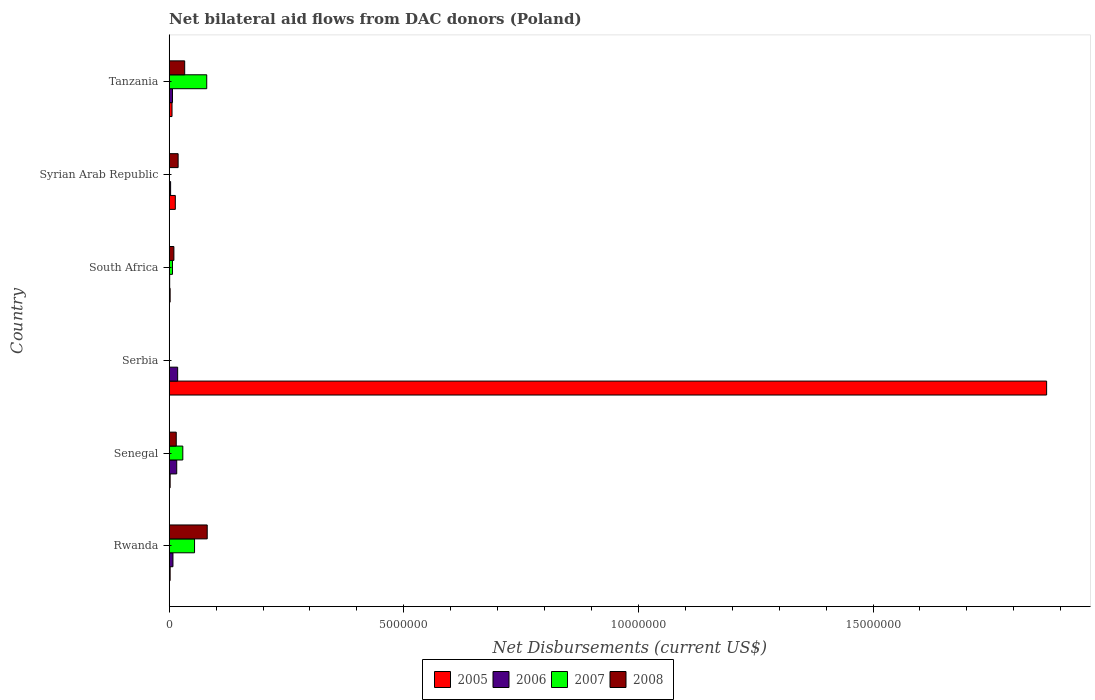How many groups of bars are there?
Provide a succinct answer. 6. Are the number of bars per tick equal to the number of legend labels?
Offer a very short reply. No. Are the number of bars on each tick of the Y-axis equal?
Keep it short and to the point. No. How many bars are there on the 2nd tick from the bottom?
Make the answer very short. 4. What is the label of the 6th group of bars from the top?
Your answer should be very brief. Rwanda. In how many cases, is the number of bars for a given country not equal to the number of legend labels?
Provide a succinct answer. 2. Across all countries, what is the maximum net bilateral aid flows in 2005?
Give a very brief answer. 1.87e+07. In which country was the net bilateral aid flows in 2008 maximum?
Keep it short and to the point. Rwanda. What is the total net bilateral aid flows in 2005 in the graph?
Your answer should be compact. 1.90e+07. What is the difference between the net bilateral aid flows in 2006 in Senegal and that in Serbia?
Offer a very short reply. -2.00e+04. What is the difference between the net bilateral aid flows in 2006 in Rwanda and the net bilateral aid flows in 2008 in Senegal?
Keep it short and to the point. -7.00e+04. What is the average net bilateral aid flows in 2007 per country?
Give a very brief answer. 2.83e+05. What is the ratio of the net bilateral aid flows in 2005 in Senegal to that in Serbia?
Offer a very short reply. 0. Is the net bilateral aid flows in 2006 in Senegal less than that in Serbia?
Your response must be concise. Yes. What is the difference between the highest and the lowest net bilateral aid flows in 2006?
Keep it short and to the point. 1.70e+05. In how many countries, is the net bilateral aid flows in 2005 greater than the average net bilateral aid flows in 2005 taken over all countries?
Your answer should be very brief. 1. How many bars are there?
Keep it short and to the point. 21. How many countries are there in the graph?
Give a very brief answer. 6. What is the difference between two consecutive major ticks on the X-axis?
Provide a short and direct response. 5.00e+06. Does the graph contain any zero values?
Give a very brief answer. Yes. Does the graph contain grids?
Offer a terse response. No. How many legend labels are there?
Offer a very short reply. 4. What is the title of the graph?
Give a very brief answer. Net bilateral aid flows from DAC donors (Poland). Does "2001" appear as one of the legend labels in the graph?
Offer a terse response. No. What is the label or title of the X-axis?
Your answer should be very brief. Net Disbursements (current US$). What is the label or title of the Y-axis?
Offer a terse response. Country. What is the Net Disbursements (current US$) of 2005 in Rwanda?
Ensure brevity in your answer.  2.00e+04. What is the Net Disbursements (current US$) in 2006 in Rwanda?
Your answer should be very brief. 8.00e+04. What is the Net Disbursements (current US$) in 2007 in Rwanda?
Provide a short and direct response. 5.40e+05. What is the Net Disbursements (current US$) in 2008 in Rwanda?
Offer a terse response. 8.10e+05. What is the Net Disbursements (current US$) of 2005 in Serbia?
Your answer should be compact. 1.87e+07. What is the Net Disbursements (current US$) in 2007 in Serbia?
Your response must be concise. 0. What is the Net Disbursements (current US$) of 2008 in Serbia?
Make the answer very short. 0. What is the Net Disbursements (current US$) in 2005 in South Africa?
Your answer should be very brief. 2.00e+04. What is the Net Disbursements (current US$) in 2005 in Syrian Arab Republic?
Your response must be concise. 1.30e+05. What is the Net Disbursements (current US$) of 2006 in Syrian Arab Republic?
Make the answer very short. 3.00e+04. What is the Net Disbursements (current US$) of 2008 in Syrian Arab Republic?
Provide a succinct answer. 1.90e+05. What is the Net Disbursements (current US$) of 2005 in Tanzania?
Make the answer very short. 6.00e+04. What is the Net Disbursements (current US$) of 2008 in Tanzania?
Ensure brevity in your answer.  3.30e+05. Across all countries, what is the maximum Net Disbursements (current US$) of 2005?
Provide a succinct answer. 1.87e+07. Across all countries, what is the maximum Net Disbursements (current US$) in 2006?
Provide a short and direct response. 1.80e+05. Across all countries, what is the maximum Net Disbursements (current US$) of 2007?
Make the answer very short. 8.00e+05. Across all countries, what is the maximum Net Disbursements (current US$) in 2008?
Your response must be concise. 8.10e+05. Across all countries, what is the minimum Net Disbursements (current US$) of 2005?
Give a very brief answer. 2.00e+04. Across all countries, what is the minimum Net Disbursements (current US$) of 2007?
Provide a short and direct response. 0. Across all countries, what is the minimum Net Disbursements (current US$) in 2008?
Make the answer very short. 0. What is the total Net Disbursements (current US$) in 2005 in the graph?
Give a very brief answer. 1.90e+07. What is the total Net Disbursements (current US$) in 2006 in the graph?
Ensure brevity in your answer.  5.30e+05. What is the total Net Disbursements (current US$) of 2007 in the graph?
Provide a short and direct response. 1.70e+06. What is the total Net Disbursements (current US$) of 2008 in the graph?
Offer a very short reply. 1.58e+06. What is the difference between the Net Disbursements (current US$) of 2005 in Rwanda and that in Senegal?
Provide a succinct answer. 0. What is the difference between the Net Disbursements (current US$) of 2006 in Rwanda and that in Senegal?
Make the answer very short. -8.00e+04. What is the difference between the Net Disbursements (current US$) in 2008 in Rwanda and that in Senegal?
Provide a succinct answer. 6.60e+05. What is the difference between the Net Disbursements (current US$) in 2005 in Rwanda and that in Serbia?
Your response must be concise. -1.87e+07. What is the difference between the Net Disbursements (current US$) of 2006 in Rwanda and that in Serbia?
Make the answer very short. -1.00e+05. What is the difference between the Net Disbursements (current US$) of 2007 in Rwanda and that in South Africa?
Provide a short and direct response. 4.70e+05. What is the difference between the Net Disbursements (current US$) in 2008 in Rwanda and that in South Africa?
Your answer should be compact. 7.10e+05. What is the difference between the Net Disbursements (current US$) of 2005 in Rwanda and that in Syrian Arab Republic?
Offer a very short reply. -1.10e+05. What is the difference between the Net Disbursements (current US$) of 2008 in Rwanda and that in Syrian Arab Republic?
Ensure brevity in your answer.  6.20e+05. What is the difference between the Net Disbursements (current US$) of 2005 in Rwanda and that in Tanzania?
Provide a succinct answer. -4.00e+04. What is the difference between the Net Disbursements (current US$) in 2006 in Rwanda and that in Tanzania?
Give a very brief answer. 10000. What is the difference between the Net Disbursements (current US$) of 2005 in Senegal and that in Serbia?
Ensure brevity in your answer.  -1.87e+07. What is the difference between the Net Disbursements (current US$) of 2005 in Senegal and that in South Africa?
Provide a succinct answer. 0. What is the difference between the Net Disbursements (current US$) of 2006 in Senegal and that in South Africa?
Your response must be concise. 1.50e+05. What is the difference between the Net Disbursements (current US$) in 2007 in Senegal and that in South Africa?
Offer a terse response. 2.20e+05. What is the difference between the Net Disbursements (current US$) in 2006 in Senegal and that in Syrian Arab Republic?
Offer a very short reply. 1.30e+05. What is the difference between the Net Disbursements (current US$) in 2008 in Senegal and that in Syrian Arab Republic?
Your answer should be very brief. -4.00e+04. What is the difference between the Net Disbursements (current US$) of 2007 in Senegal and that in Tanzania?
Your answer should be compact. -5.10e+05. What is the difference between the Net Disbursements (current US$) of 2008 in Senegal and that in Tanzania?
Offer a very short reply. -1.80e+05. What is the difference between the Net Disbursements (current US$) of 2005 in Serbia and that in South Africa?
Give a very brief answer. 1.87e+07. What is the difference between the Net Disbursements (current US$) of 2005 in Serbia and that in Syrian Arab Republic?
Offer a very short reply. 1.86e+07. What is the difference between the Net Disbursements (current US$) in 2006 in Serbia and that in Syrian Arab Republic?
Your answer should be very brief. 1.50e+05. What is the difference between the Net Disbursements (current US$) of 2005 in Serbia and that in Tanzania?
Keep it short and to the point. 1.86e+07. What is the difference between the Net Disbursements (current US$) in 2005 in South Africa and that in Syrian Arab Republic?
Make the answer very short. -1.10e+05. What is the difference between the Net Disbursements (current US$) in 2008 in South Africa and that in Syrian Arab Republic?
Provide a short and direct response. -9.00e+04. What is the difference between the Net Disbursements (current US$) of 2005 in South Africa and that in Tanzania?
Provide a succinct answer. -4.00e+04. What is the difference between the Net Disbursements (current US$) of 2006 in South Africa and that in Tanzania?
Your response must be concise. -6.00e+04. What is the difference between the Net Disbursements (current US$) in 2007 in South Africa and that in Tanzania?
Provide a succinct answer. -7.30e+05. What is the difference between the Net Disbursements (current US$) of 2005 in Syrian Arab Republic and that in Tanzania?
Your response must be concise. 7.00e+04. What is the difference between the Net Disbursements (current US$) of 2006 in Rwanda and the Net Disbursements (current US$) of 2008 in Senegal?
Offer a terse response. -7.00e+04. What is the difference between the Net Disbursements (current US$) of 2007 in Rwanda and the Net Disbursements (current US$) of 2008 in Senegal?
Offer a terse response. 3.90e+05. What is the difference between the Net Disbursements (current US$) in 2005 in Rwanda and the Net Disbursements (current US$) in 2006 in Serbia?
Offer a terse response. -1.60e+05. What is the difference between the Net Disbursements (current US$) of 2005 in Rwanda and the Net Disbursements (current US$) of 2007 in South Africa?
Your answer should be very brief. -5.00e+04. What is the difference between the Net Disbursements (current US$) in 2005 in Rwanda and the Net Disbursements (current US$) in 2008 in South Africa?
Your answer should be compact. -8.00e+04. What is the difference between the Net Disbursements (current US$) in 2006 in Rwanda and the Net Disbursements (current US$) in 2008 in South Africa?
Keep it short and to the point. -2.00e+04. What is the difference between the Net Disbursements (current US$) of 2005 in Rwanda and the Net Disbursements (current US$) of 2006 in Syrian Arab Republic?
Your answer should be compact. -10000. What is the difference between the Net Disbursements (current US$) of 2006 in Rwanda and the Net Disbursements (current US$) of 2008 in Syrian Arab Republic?
Your answer should be very brief. -1.10e+05. What is the difference between the Net Disbursements (current US$) of 2007 in Rwanda and the Net Disbursements (current US$) of 2008 in Syrian Arab Republic?
Keep it short and to the point. 3.50e+05. What is the difference between the Net Disbursements (current US$) of 2005 in Rwanda and the Net Disbursements (current US$) of 2007 in Tanzania?
Ensure brevity in your answer.  -7.80e+05. What is the difference between the Net Disbursements (current US$) in 2005 in Rwanda and the Net Disbursements (current US$) in 2008 in Tanzania?
Your response must be concise. -3.10e+05. What is the difference between the Net Disbursements (current US$) in 2006 in Rwanda and the Net Disbursements (current US$) in 2007 in Tanzania?
Keep it short and to the point. -7.20e+05. What is the difference between the Net Disbursements (current US$) in 2006 in Rwanda and the Net Disbursements (current US$) in 2008 in Tanzania?
Provide a succinct answer. -2.50e+05. What is the difference between the Net Disbursements (current US$) of 2007 in Rwanda and the Net Disbursements (current US$) of 2008 in Tanzania?
Give a very brief answer. 2.10e+05. What is the difference between the Net Disbursements (current US$) in 2005 in Senegal and the Net Disbursements (current US$) in 2006 in South Africa?
Your response must be concise. 10000. What is the difference between the Net Disbursements (current US$) of 2005 in Senegal and the Net Disbursements (current US$) of 2008 in South Africa?
Your response must be concise. -8.00e+04. What is the difference between the Net Disbursements (current US$) of 2006 in Senegal and the Net Disbursements (current US$) of 2008 in South Africa?
Your answer should be compact. 6.00e+04. What is the difference between the Net Disbursements (current US$) of 2005 in Senegal and the Net Disbursements (current US$) of 2006 in Syrian Arab Republic?
Your answer should be very brief. -10000. What is the difference between the Net Disbursements (current US$) in 2005 in Senegal and the Net Disbursements (current US$) in 2008 in Syrian Arab Republic?
Your answer should be compact. -1.70e+05. What is the difference between the Net Disbursements (current US$) of 2005 in Senegal and the Net Disbursements (current US$) of 2007 in Tanzania?
Your response must be concise. -7.80e+05. What is the difference between the Net Disbursements (current US$) in 2005 in Senegal and the Net Disbursements (current US$) in 2008 in Tanzania?
Offer a terse response. -3.10e+05. What is the difference between the Net Disbursements (current US$) in 2006 in Senegal and the Net Disbursements (current US$) in 2007 in Tanzania?
Offer a very short reply. -6.40e+05. What is the difference between the Net Disbursements (current US$) of 2005 in Serbia and the Net Disbursements (current US$) of 2006 in South Africa?
Your answer should be very brief. 1.87e+07. What is the difference between the Net Disbursements (current US$) of 2005 in Serbia and the Net Disbursements (current US$) of 2007 in South Africa?
Your answer should be compact. 1.86e+07. What is the difference between the Net Disbursements (current US$) in 2005 in Serbia and the Net Disbursements (current US$) in 2008 in South Africa?
Your response must be concise. 1.86e+07. What is the difference between the Net Disbursements (current US$) of 2006 in Serbia and the Net Disbursements (current US$) of 2008 in South Africa?
Your response must be concise. 8.00e+04. What is the difference between the Net Disbursements (current US$) in 2005 in Serbia and the Net Disbursements (current US$) in 2006 in Syrian Arab Republic?
Provide a succinct answer. 1.87e+07. What is the difference between the Net Disbursements (current US$) of 2005 in Serbia and the Net Disbursements (current US$) of 2008 in Syrian Arab Republic?
Ensure brevity in your answer.  1.85e+07. What is the difference between the Net Disbursements (current US$) in 2005 in Serbia and the Net Disbursements (current US$) in 2006 in Tanzania?
Your response must be concise. 1.86e+07. What is the difference between the Net Disbursements (current US$) of 2005 in Serbia and the Net Disbursements (current US$) of 2007 in Tanzania?
Provide a succinct answer. 1.79e+07. What is the difference between the Net Disbursements (current US$) of 2005 in Serbia and the Net Disbursements (current US$) of 2008 in Tanzania?
Offer a very short reply. 1.84e+07. What is the difference between the Net Disbursements (current US$) of 2006 in Serbia and the Net Disbursements (current US$) of 2007 in Tanzania?
Your response must be concise. -6.20e+05. What is the difference between the Net Disbursements (current US$) of 2005 in South Africa and the Net Disbursements (current US$) of 2008 in Syrian Arab Republic?
Your answer should be compact. -1.70e+05. What is the difference between the Net Disbursements (current US$) of 2005 in South Africa and the Net Disbursements (current US$) of 2007 in Tanzania?
Offer a very short reply. -7.80e+05. What is the difference between the Net Disbursements (current US$) in 2005 in South Africa and the Net Disbursements (current US$) in 2008 in Tanzania?
Offer a terse response. -3.10e+05. What is the difference between the Net Disbursements (current US$) of 2006 in South Africa and the Net Disbursements (current US$) of 2007 in Tanzania?
Ensure brevity in your answer.  -7.90e+05. What is the difference between the Net Disbursements (current US$) of 2006 in South Africa and the Net Disbursements (current US$) of 2008 in Tanzania?
Give a very brief answer. -3.20e+05. What is the difference between the Net Disbursements (current US$) in 2005 in Syrian Arab Republic and the Net Disbursements (current US$) in 2006 in Tanzania?
Provide a succinct answer. 6.00e+04. What is the difference between the Net Disbursements (current US$) in 2005 in Syrian Arab Republic and the Net Disbursements (current US$) in 2007 in Tanzania?
Provide a short and direct response. -6.70e+05. What is the difference between the Net Disbursements (current US$) in 2006 in Syrian Arab Republic and the Net Disbursements (current US$) in 2007 in Tanzania?
Ensure brevity in your answer.  -7.70e+05. What is the average Net Disbursements (current US$) of 2005 per country?
Offer a very short reply. 3.16e+06. What is the average Net Disbursements (current US$) in 2006 per country?
Make the answer very short. 8.83e+04. What is the average Net Disbursements (current US$) in 2007 per country?
Your answer should be very brief. 2.83e+05. What is the average Net Disbursements (current US$) in 2008 per country?
Provide a short and direct response. 2.63e+05. What is the difference between the Net Disbursements (current US$) in 2005 and Net Disbursements (current US$) in 2006 in Rwanda?
Make the answer very short. -6.00e+04. What is the difference between the Net Disbursements (current US$) in 2005 and Net Disbursements (current US$) in 2007 in Rwanda?
Keep it short and to the point. -5.20e+05. What is the difference between the Net Disbursements (current US$) in 2005 and Net Disbursements (current US$) in 2008 in Rwanda?
Provide a short and direct response. -7.90e+05. What is the difference between the Net Disbursements (current US$) in 2006 and Net Disbursements (current US$) in 2007 in Rwanda?
Make the answer very short. -4.60e+05. What is the difference between the Net Disbursements (current US$) of 2006 and Net Disbursements (current US$) of 2008 in Rwanda?
Provide a succinct answer. -7.30e+05. What is the difference between the Net Disbursements (current US$) in 2007 and Net Disbursements (current US$) in 2008 in Rwanda?
Offer a very short reply. -2.70e+05. What is the difference between the Net Disbursements (current US$) in 2005 and Net Disbursements (current US$) in 2007 in Senegal?
Your answer should be compact. -2.70e+05. What is the difference between the Net Disbursements (current US$) of 2005 and Net Disbursements (current US$) of 2008 in Senegal?
Your answer should be compact. -1.30e+05. What is the difference between the Net Disbursements (current US$) in 2006 and Net Disbursements (current US$) in 2007 in Senegal?
Offer a terse response. -1.30e+05. What is the difference between the Net Disbursements (current US$) in 2007 and Net Disbursements (current US$) in 2008 in Senegal?
Offer a very short reply. 1.40e+05. What is the difference between the Net Disbursements (current US$) of 2005 and Net Disbursements (current US$) of 2006 in Serbia?
Keep it short and to the point. 1.85e+07. What is the difference between the Net Disbursements (current US$) of 2005 and Net Disbursements (current US$) of 2006 in South Africa?
Ensure brevity in your answer.  10000. What is the difference between the Net Disbursements (current US$) of 2006 and Net Disbursements (current US$) of 2008 in South Africa?
Offer a terse response. -9.00e+04. What is the difference between the Net Disbursements (current US$) in 2005 and Net Disbursements (current US$) in 2008 in Syrian Arab Republic?
Offer a very short reply. -6.00e+04. What is the difference between the Net Disbursements (current US$) of 2006 and Net Disbursements (current US$) of 2008 in Syrian Arab Republic?
Offer a very short reply. -1.60e+05. What is the difference between the Net Disbursements (current US$) in 2005 and Net Disbursements (current US$) in 2007 in Tanzania?
Provide a short and direct response. -7.40e+05. What is the difference between the Net Disbursements (current US$) in 2005 and Net Disbursements (current US$) in 2008 in Tanzania?
Keep it short and to the point. -2.70e+05. What is the difference between the Net Disbursements (current US$) of 2006 and Net Disbursements (current US$) of 2007 in Tanzania?
Your response must be concise. -7.30e+05. What is the difference between the Net Disbursements (current US$) of 2006 and Net Disbursements (current US$) of 2008 in Tanzania?
Your answer should be compact. -2.60e+05. What is the ratio of the Net Disbursements (current US$) of 2005 in Rwanda to that in Senegal?
Offer a very short reply. 1. What is the ratio of the Net Disbursements (current US$) in 2007 in Rwanda to that in Senegal?
Ensure brevity in your answer.  1.86. What is the ratio of the Net Disbursements (current US$) in 2008 in Rwanda to that in Senegal?
Your answer should be very brief. 5.4. What is the ratio of the Net Disbursements (current US$) of 2005 in Rwanda to that in Serbia?
Provide a succinct answer. 0. What is the ratio of the Net Disbursements (current US$) of 2006 in Rwanda to that in Serbia?
Your answer should be compact. 0.44. What is the ratio of the Net Disbursements (current US$) in 2005 in Rwanda to that in South Africa?
Offer a very short reply. 1. What is the ratio of the Net Disbursements (current US$) of 2006 in Rwanda to that in South Africa?
Give a very brief answer. 8. What is the ratio of the Net Disbursements (current US$) of 2007 in Rwanda to that in South Africa?
Keep it short and to the point. 7.71. What is the ratio of the Net Disbursements (current US$) in 2008 in Rwanda to that in South Africa?
Your answer should be very brief. 8.1. What is the ratio of the Net Disbursements (current US$) in 2005 in Rwanda to that in Syrian Arab Republic?
Provide a short and direct response. 0.15. What is the ratio of the Net Disbursements (current US$) in 2006 in Rwanda to that in Syrian Arab Republic?
Offer a terse response. 2.67. What is the ratio of the Net Disbursements (current US$) of 2008 in Rwanda to that in Syrian Arab Republic?
Your answer should be compact. 4.26. What is the ratio of the Net Disbursements (current US$) in 2005 in Rwanda to that in Tanzania?
Your answer should be compact. 0.33. What is the ratio of the Net Disbursements (current US$) of 2007 in Rwanda to that in Tanzania?
Your answer should be very brief. 0.68. What is the ratio of the Net Disbursements (current US$) in 2008 in Rwanda to that in Tanzania?
Ensure brevity in your answer.  2.45. What is the ratio of the Net Disbursements (current US$) of 2005 in Senegal to that in Serbia?
Provide a short and direct response. 0. What is the ratio of the Net Disbursements (current US$) of 2006 in Senegal to that in Serbia?
Provide a short and direct response. 0.89. What is the ratio of the Net Disbursements (current US$) in 2005 in Senegal to that in South Africa?
Your answer should be very brief. 1. What is the ratio of the Net Disbursements (current US$) of 2007 in Senegal to that in South Africa?
Provide a succinct answer. 4.14. What is the ratio of the Net Disbursements (current US$) of 2005 in Senegal to that in Syrian Arab Republic?
Give a very brief answer. 0.15. What is the ratio of the Net Disbursements (current US$) in 2006 in Senegal to that in Syrian Arab Republic?
Offer a terse response. 5.33. What is the ratio of the Net Disbursements (current US$) in 2008 in Senegal to that in Syrian Arab Republic?
Offer a very short reply. 0.79. What is the ratio of the Net Disbursements (current US$) in 2006 in Senegal to that in Tanzania?
Give a very brief answer. 2.29. What is the ratio of the Net Disbursements (current US$) of 2007 in Senegal to that in Tanzania?
Your answer should be very brief. 0.36. What is the ratio of the Net Disbursements (current US$) of 2008 in Senegal to that in Tanzania?
Keep it short and to the point. 0.45. What is the ratio of the Net Disbursements (current US$) in 2005 in Serbia to that in South Africa?
Keep it short and to the point. 935. What is the ratio of the Net Disbursements (current US$) of 2005 in Serbia to that in Syrian Arab Republic?
Provide a short and direct response. 143.85. What is the ratio of the Net Disbursements (current US$) in 2006 in Serbia to that in Syrian Arab Republic?
Offer a terse response. 6. What is the ratio of the Net Disbursements (current US$) of 2005 in Serbia to that in Tanzania?
Your answer should be very brief. 311.67. What is the ratio of the Net Disbursements (current US$) of 2006 in Serbia to that in Tanzania?
Ensure brevity in your answer.  2.57. What is the ratio of the Net Disbursements (current US$) in 2005 in South Africa to that in Syrian Arab Republic?
Your answer should be very brief. 0.15. What is the ratio of the Net Disbursements (current US$) in 2006 in South Africa to that in Syrian Arab Republic?
Keep it short and to the point. 0.33. What is the ratio of the Net Disbursements (current US$) in 2008 in South Africa to that in Syrian Arab Republic?
Offer a terse response. 0.53. What is the ratio of the Net Disbursements (current US$) of 2005 in South Africa to that in Tanzania?
Ensure brevity in your answer.  0.33. What is the ratio of the Net Disbursements (current US$) in 2006 in South Africa to that in Tanzania?
Provide a succinct answer. 0.14. What is the ratio of the Net Disbursements (current US$) in 2007 in South Africa to that in Tanzania?
Your answer should be very brief. 0.09. What is the ratio of the Net Disbursements (current US$) of 2008 in South Africa to that in Tanzania?
Provide a succinct answer. 0.3. What is the ratio of the Net Disbursements (current US$) in 2005 in Syrian Arab Republic to that in Tanzania?
Provide a short and direct response. 2.17. What is the ratio of the Net Disbursements (current US$) in 2006 in Syrian Arab Republic to that in Tanzania?
Give a very brief answer. 0.43. What is the ratio of the Net Disbursements (current US$) in 2008 in Syrian Arab Republic to that in Tanzania?
Your answer should be very brief. 0.58. What is the difference between the highest and the second highest Net Disbursements (current US$) in 2005?
Ensure brevity in your answer.  1.86e+07. What is the difference between the highest and the second highest Net Disbursements (current US$) in 2006?
Give a very brief answer. 2.00e+04. What is the difference between the highest and the second highest Net Disbursements (current US$) of 2008?
Keep it short and to the point. 4.80e+05. What is the difference between the highest and the lowest Net Disbursements (current US$) of 2005?
Make the answer very short. 1.87e+07. What is the difference between the highest and the lowest Net Disbursements (current US$) of 2007?
Your response must be concise. 8.00e+05. What is the difference between the highest and the lowest Net Disbursements (current US$) in 2008?
Offer a terse response. 8.10e+05. 